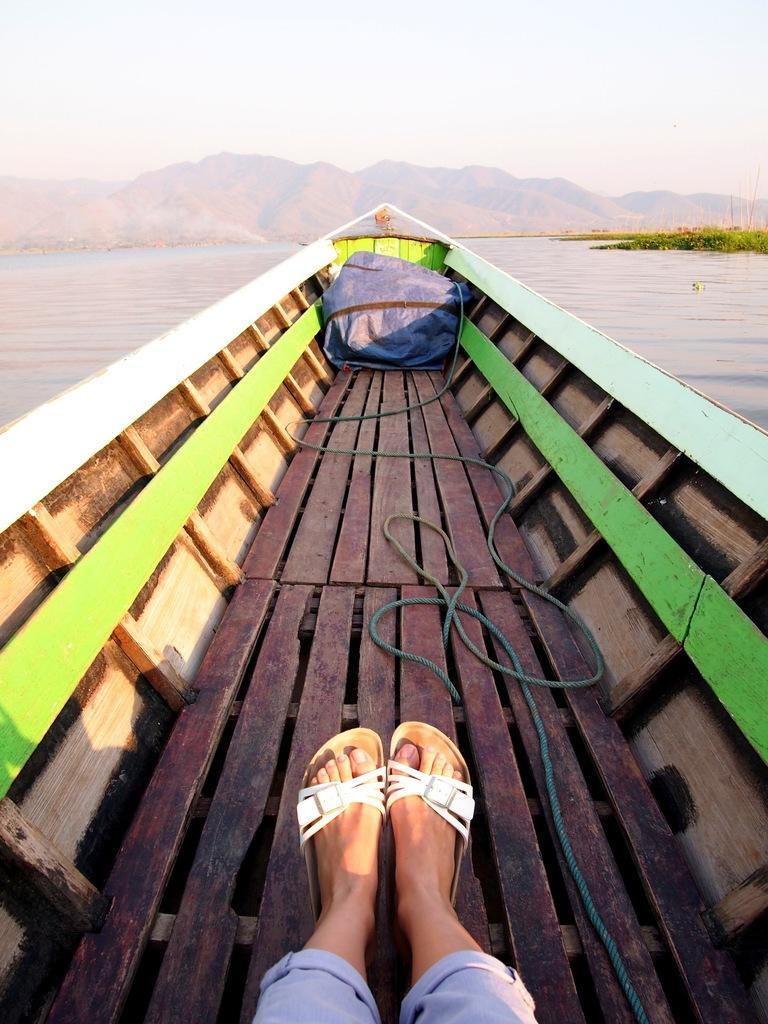Could you give a brief overview of what you see in this image? In the picture we can see some person's leg sitting in a boat and in the background there is water, there are some mountains and clear sky. 